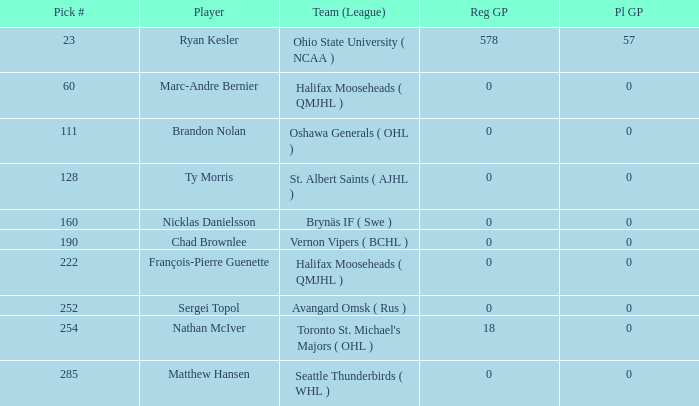What's the highest Pl GP with a Reg GP over 18? 57.0. Can you give me this table as a dict? {'header': ['Pick #', 'Player', 'Team (League)', 'Reg GP', 'Pl GP'], 'rows': [['23', 'Ryan Kesler', 'Ohio State University ( NCAA )', '578', '57'], ['60', 'Marc-Andre Bernier', 'Halifax Mooseheads ( QMJHL )', '0', '0'], ['111', 'Brandon Nolan', 'Oshawa Generals ( OHL )', '0', '0'], ['128', 'Ty Morris', 'St. Albert Saints ( AJHL )', '0', '0'], ['160', 'Nicklas Danielsson', 'Brynäs IF ( Swe )', '0', '0'], ['190', 'Chad Brownlee', 'Vernon Vipers ( BCHL )', '0', '0'], ['222', 'François-Pierre Guenette', 'Halifax Mooseheads ( QMJHL )', '0', '0'], ['252', 'Sergei Topol', 'Avangard Omsk ( Rus )', '0', '0'], ['254', 'Nathan McIver', "Toronto St. Michael's Majors ( OHL )", '18', '0'], ['285', 'Matthew Hansen', 'Seattle Thunderbirds ( WHL )', '0', '0']]} 